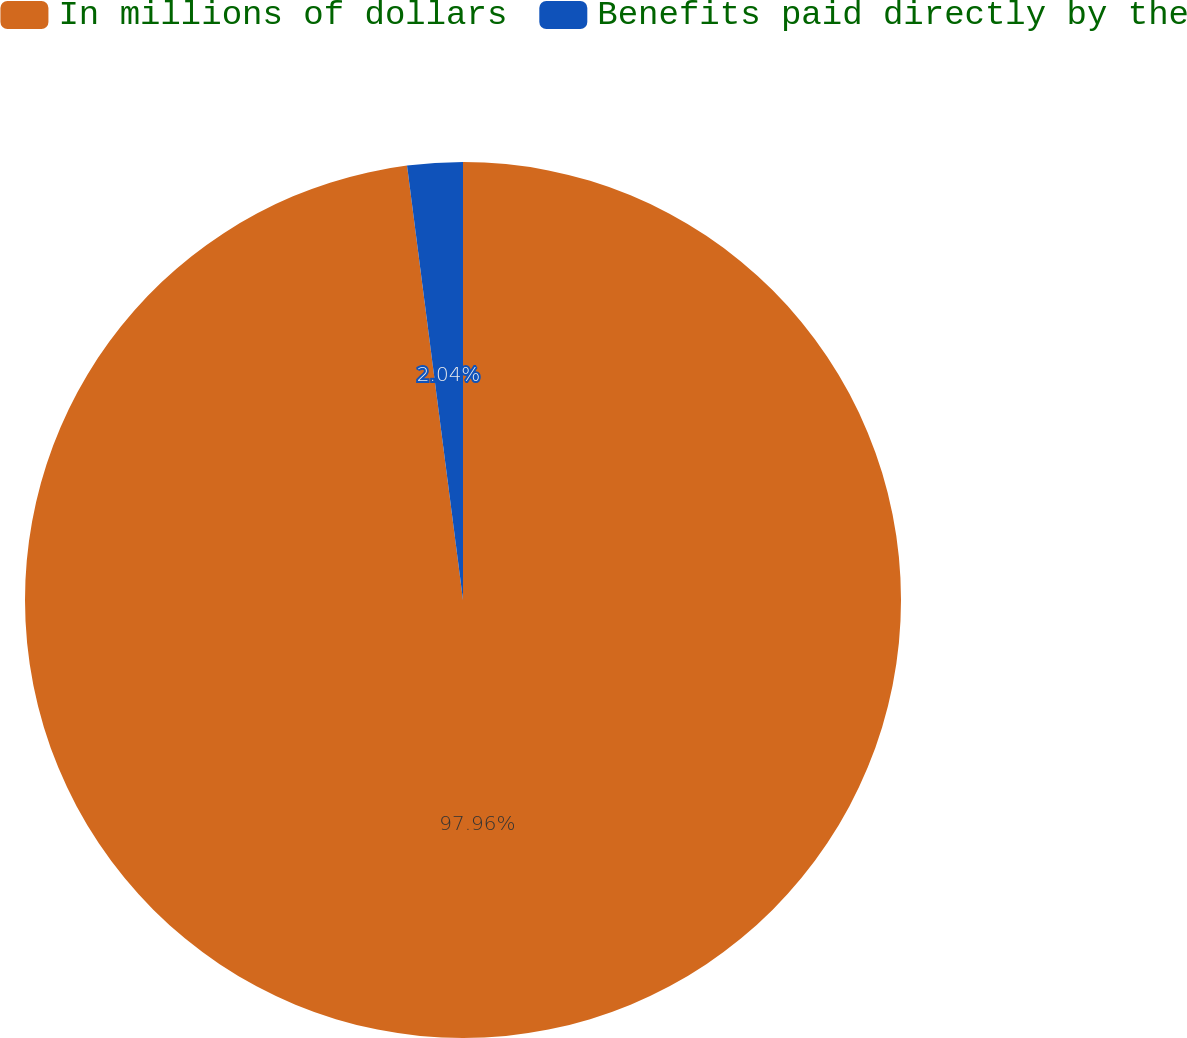<chart> <loc_0><loc_0><loc_500><loc_500><pie_chart><fcel>In millions of dollars<fcel>Benefits paid directly by the<nl><fcel>97.96%<fcel>2.04%<nl></chart> 